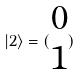Convert formula to latex. <formula><loc_0><loc_0><loc_500><loc_500>| 2 \rangle = ( \begin{matrix} 0 \\ 1 \end{matrix} )</formula> 